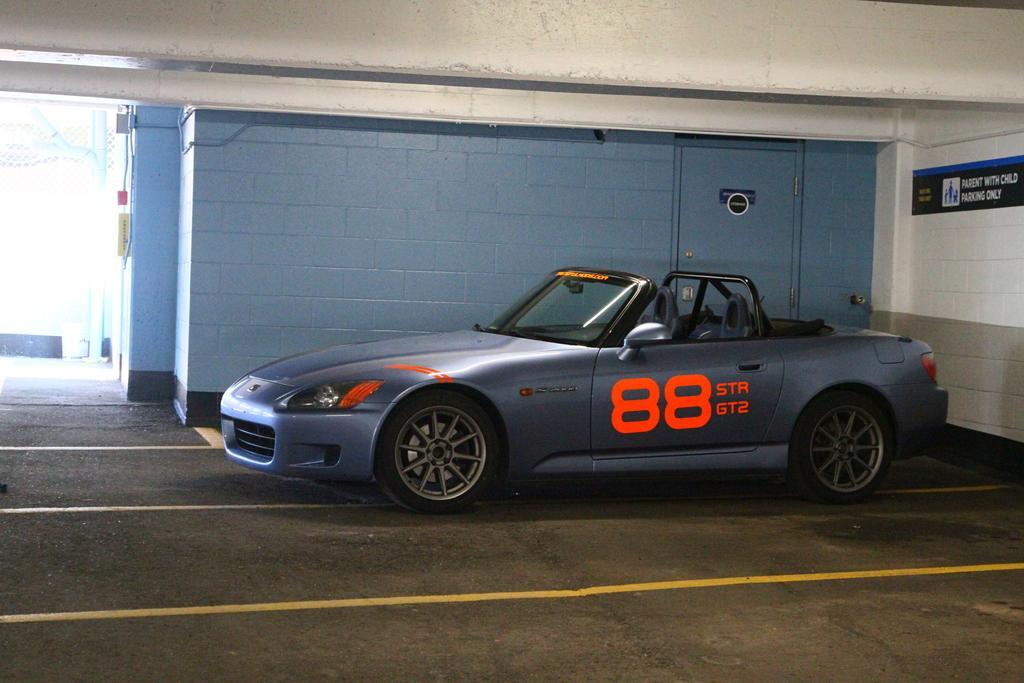Describe this image in one or two sentences. In the center of the picture there is a car, beside the car there is a door. In the center of the picture it is well. On the left there is a building. 